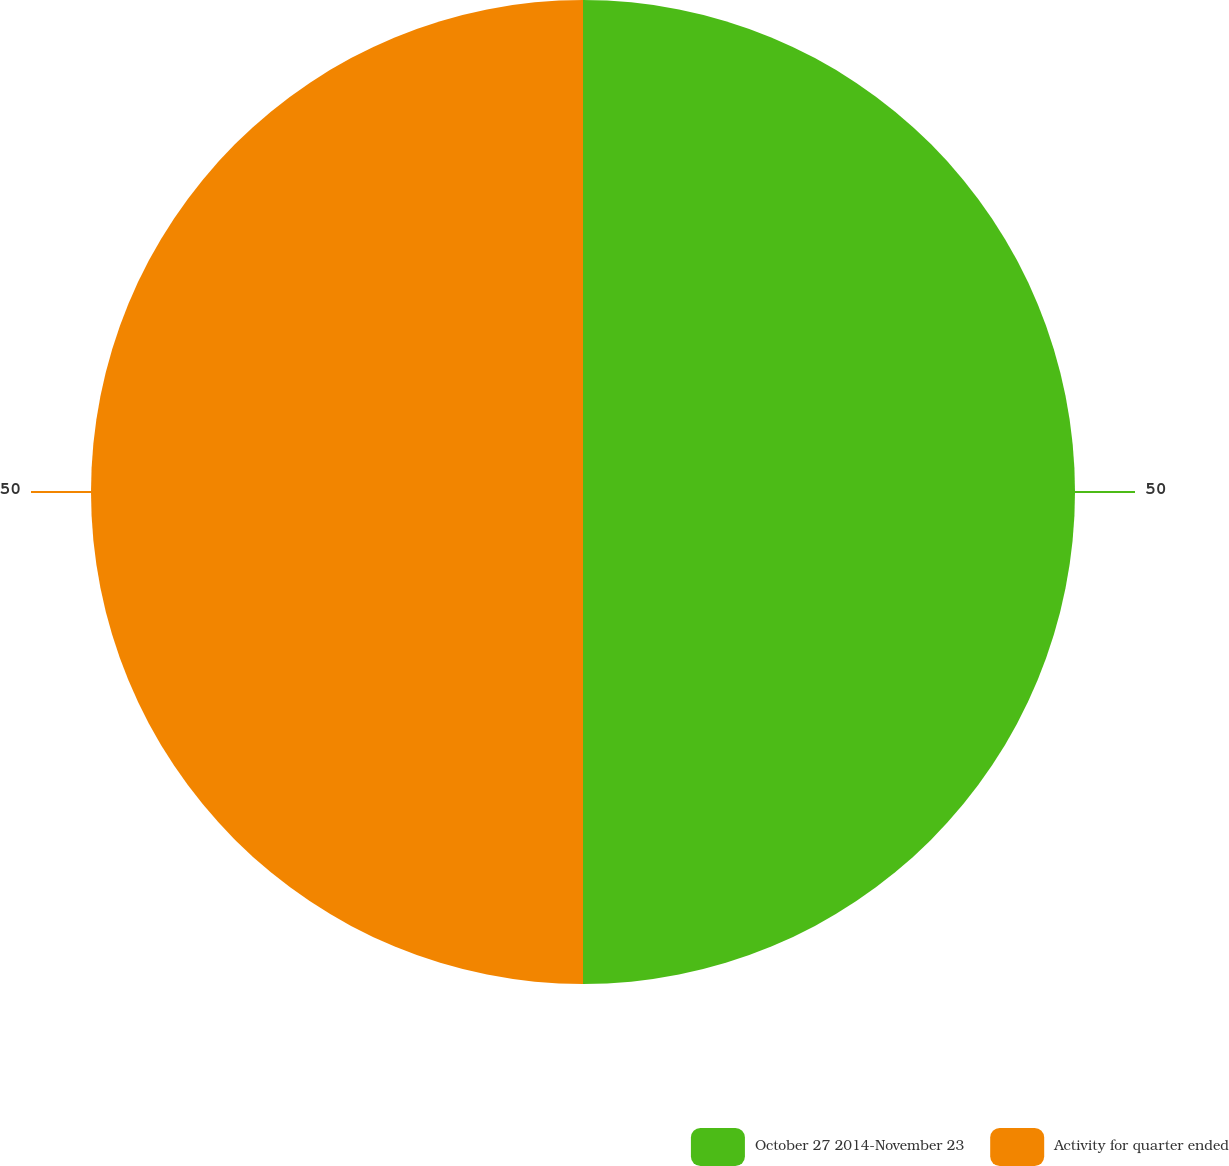Convert chart to OTSL. <chart><loc_0><loc_0><loc_500><loc_500><pie_chart><fcel>October 27 2014-November 23<fcel>Activity for quarter ended<nl><fcel>50.0%<fcel>50.0%<nl></chart> 